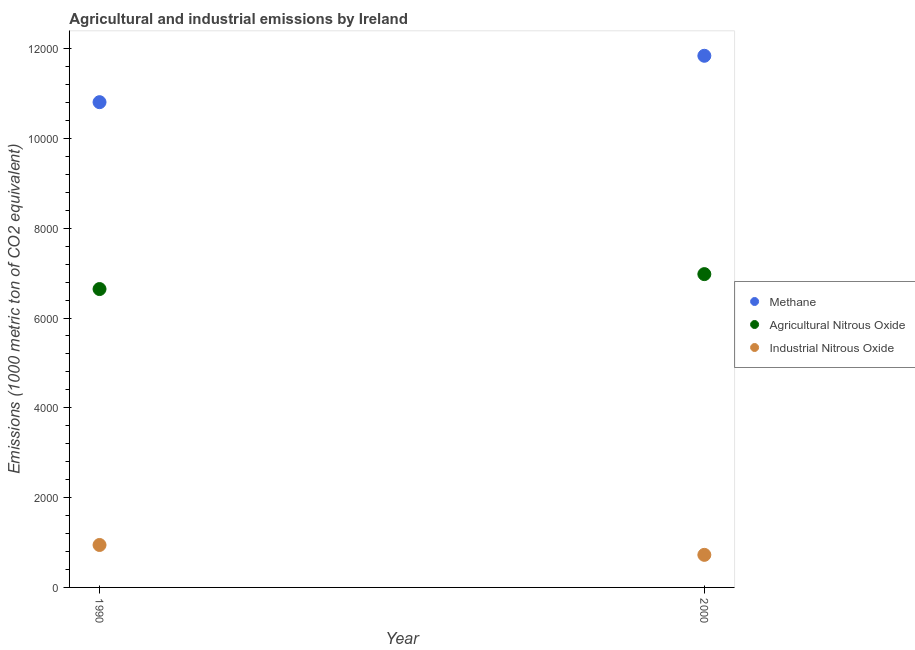How many different coloured dotlines are there?
Offer a terse response. 3. What is the amount of agricultural nitrous oxide emissions in 1990?
Offer a terse response. 6644.8. Across all years, what is the maximum amount of agricultural nitrous oxide emissions?
Offer a very short reply. 6977.3. Across all years, what is the minimum amount of industrial nitrous oxide emissions?
Your answer should be very brief. 725.4. In which year was the amount of methane emissions maximum?
Your answer should be compact. 2000. What is the total amount of methane emissions in the graph?
Give a very brief answer. 2.26e+04. What is the difference between the amount of industrial nitrous oxide emissions in 1990 and that in 2000?
Ensure brevity in your answer.  219.9. What is the difference between the amount of industrial nitrous oxide emissions in 1990 and the amount of methane emissions in 2000?
Offer a terse response. -1.09e+04. What is the average amount of agricultural nitrous oxide emissions per year?
Your answer should be very brief. 6811.05. In the year 1990, what is the difference between the amount of industrial nitrous oxide emissions and amount of methane emissions?
Your answer should be compact. -9861.2. In how many years, is the amount of agricultural nitrous oxide emissions greater than 5200 metric ton?
Give a very brief answer. 2. What is the ratio of the amount of agricultural nitrous oxide emissions in 1990 to that in 2000?
Make the answer very short. 0.95. Is the amount of industrial nitrous oxide emissions in 1990 less than that in 2000?
Keep it short and to the point. No. Is it the case that in every year, the sum of the amount of methane emissions and amount of agricultural nitrous oxide emissions is greater than the amount of industrial nitrous oxide emissions?
Offer a very short reply. Yes. Does the amount of methane emissions monotonically increase over the years?
Your answer should be compact. Yes. Is the amount of agricultural nitrous oxide emissions strictly greater than the amount of methane emissions over the years?
Your answer should be compact. No. How many dotlines are there?
Keep it short and to the point. 3. How many years are there in the graph?
Give a very brief answer. 2. Does the graph contain any zero values?
Provide a succinct answer. No. Does the graph contain grids?
Give a very brief answer. No. Where does the legend appear in the graph?
Provide a succinct answer. Center right. What is the title of the graph?
Offer a very short reply. Agricultural and industrial emissions by Ireland. What is the label or title of the Y-axis?
Offer a terse response. Emissions (1000 metric ton of CO2 equivalent). What is the Emissions (1000 metric ton of CO2 equivalent) of Methane in 1990?
Provide a succinct answer. 1.08e+04. What is the Emissions (1000 metric ton of CO2 equivalent) of Agricultural Nitrous Oxide in 1990?
Keep it short and to the point. 6644.8. What is the Emissions (1000 metric ton of CO2 equivalent) of Industrial Nitrous Oxide in 1990?
Your answer should be very brief. 945.3. What is the Emissions (1000 metric ton of CO2 equivalent) of Methane in 2000?
Offer a very short reply. 1.18e+04. What is the Emissions (1000 metric ton of CO2 equivalent) of Agricultural Nitrous Oxide in 2000?
Provide a short and direct response. 6977.3. What is the Emissions (1000 metric ton of CO2 equivalent) of Industrial Nitrous Oxide in 2000?
Your answer should be compact. 725.4. Across all years, what is the maximum Emissions (1000 metric ton of CO2 equivalent) in Methane?
Make the answer very short. 1.18e+04. Across all years, what is the maximum Emissions (1000 metric ton of CO2 equivalent) of Agricultural Nitrous Oxide?
Your answer should be very brief. 6977.3. Across all years, what is the maximum Emissions (1000 metric ton of CO2 equivalent) of Industrial Nitrous Oxide?
Make the answer very short. 945.3. Across all years, what is the minimum Emissions (1000 metric ton of CO2 equivalent) of Methane?
Your answer should be compact. 1.08e+04. Across all years, what is the minimum Emissions (1000 metric ton of CO2 equivalent) in Agricultural Nitrous Oxide?
Make the answer very short. 6644.8. Across all years, what is the minimum Emissions (1000 metric ton of CO2 equivalent) of Industrial Nitrous Oxide?
Your answer should be compact. 725.4. What is the total Emissions (1000 metric ton of CO2 equivalent) in Methane in the graph?
Provide a succinct answer. 2.26e+04. What is the total Emissions (1000 metric ton of CO2 equivalent) of Agricultural Nitrous Oxide in the graph?
Ensure brevity in your answer.  1.36e+04. What is the total Emissions (1000 metric ton of CO2 equivalent) of Industrial Nitrous Oxide in the graph?
Make the answer very short. 1670.7. What is the difference between the Emissions (1000 metric ton of CO2 equivalent) of Methane in 1990 and that in 2000?
Your answer should be compact. -1033.1. What is the difference between the Emissions (1000 metric ton of CO2 equivalent) of Agricultural Nitrous Oxide in 1990 and that in 2000?
Offer a very short reply. -332.5. What is the difference between the Emissions (1000 metric ton of CO2 equivalent) of Industrial Nitrous Oxide in 1990 and that in 2000?
Give a very brief answer. 219.9. What is the difference between the Emissions (1000 metric ton of CO2 equivalent) of Methane in 1990 and the Emissions (1000 metric ton of CO2 equivalent) of Agricultural Nitrous Oxide in 2000?
Ensure brevity in your answer.  3829.2. What is the difference between the Emissions (1000 metric ton of CO2 equivalent) of Methane in 1990 and the Emissions (1000 metric ton of CO2 equivalent) of Industrial Nitrous Oxide in 2000?
Ensure brevity in your answer.  1.01e+04. What is the difference between the Emissions (1000 metric ton of CO2 equivalent) in Agricultural Nitrous Oxide in 1990 and the Emissions (1000 metric ton of CO2 equivalent) in Industrial Nitrous Oxide in 2000?
Give a very brief answer. 5919.4. What is the average Emissions (1000 metric ton of CO2 equivalent) of Methane per year?
Offer a very short reply. 1.13e+04. What is the average Emissions (1000 metric ton of CO2 equivalent) in Agricultural Nitrous Oxide per year?
Make the answer very short. 6811.05. What is the average Emissions (1000 metric ton of CO2 equivalent) of Industrial Nitrous Oxide per year?
Your answer should be compact. 835.35. In the year 1990, what is the difference between the Emissions (1000 metric ton of CO2 equivalent) of Methane and Emissions (1000 metric ton of CO2 equivalent) of Agricultural Nitrous Oxide?
Provide a short and direct response. 4161.7. In the year 1990, what is the difference between the Emissions (1000 metric ton of CO2 equivalent) in Methane and Emissions (1000 metric ton of CO2 equivalent) in Industrial Nitrous Oxide?
Offer a very short reply. 9861.2. In the year 1990, what is the difference between the Emissions (1000 metric ton of CO2 equivalent) of Agricultural Nitrous Oxide and Emissions (1000 metric ton of CO2 equivalent) of Industrial Nitrous Oxide?
Offer a very short reply. 5699.5. In the year 2000, what is the difference between the Emissions (1000 metric ton of CO2 equivalent) in Methane and Emissions (1000 metric ton of CO2 equivalent) in Agricultural Nitrous Oxide?
Provide a succinct answer. 4862.3. In the year 2000, what is the difference between the Emissions (1000 metric ton of CO2 equivalent) of Methane and Emissions (1000 metric ton of CO2 equivalent) of Industrial Nitrous Oxide?
Provide a succinct answer. 1.11e+04. In the year 2000, what is the difference between the Emissions (1000 metric ton of CO2 equivalent) in Agricultural Nitrous Oxide and Emissions (1000 metric ton of CO2 equivalent) in Industrial Nitrous Oxide?
Provide a succinct answer. 6251.9. What is the ratio of the Emissions (1000 metric ton of CO2 equivalent) in Methane in 1990 to that in 2000?
Your response must be concise. 0.91. What is the ratio of the Emissions (1000 metric ton of CO2 equivalent) of Agricultural Nitrous Oxide in 1990 to that in 2000?
Your answer should be very brief. 0.95. What is the ratio of the Emissions (1000 metric ton of CO2 equivalent) in Industrial Nitrous Oxide in 1990 to that in 2000?
Your answer should be very brief. 1.3. What is the difference between the highest and the second highest Emissions (1000 metric ton of CO2 equivalent) in Methane?
Ensure brevity in your answer.  1033.1. What is the difference between the highest and the second highest Emissions (1000 metric ton of CO2 equivalent) of Agricultural Nitrous Oxide?
Make the answer very short. 332.5. What is the difference between the highest and the second highest Emissions (1000 metric ton of CO2 equivalent) in Industrial Nitrous Oxide?
Your answer should be compact. 219.9. What is the difference between the highest and the lowest Emissions (1000 metric ton of CO2 equivalent) of Methane?
Offer a very short reply. 1033.1. What is the difference between the highest and the lowest Emissions (1000 metric ton of CO2 equivalent) in Agricultural Nitrous Oxide?
Offer a terse response. 332.5. What is the difference between the highest and the lowest Emissions (1000 metric ton of CO2 equivalent) of Industrial Nitrous Oxide?
Your answer should be compact. 219.9. 